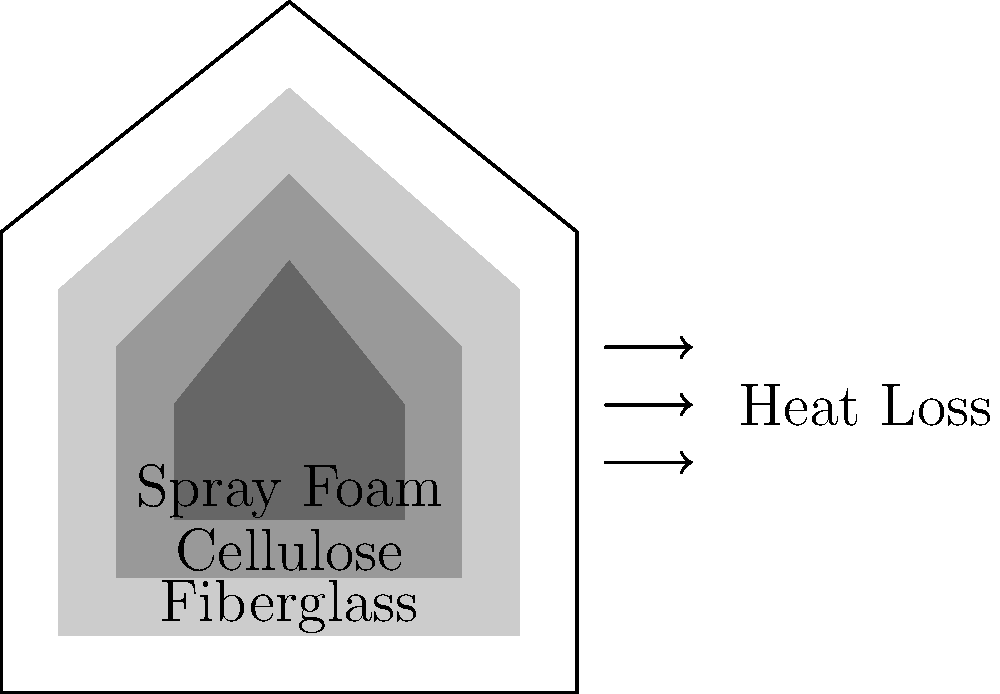In a home insulation project, three different materials are being considered: fiberglass, cellulose, and spray foam. Based on the cross-sectional diagram, which insulation material would likely provide the best thermal resistance (R-value) and reduce heat loss most effectively? Explain your reasoning considering the thickness and properties of each material. To answer this question, we need to consider the following factors:

1. Thickness: In general, thicker insulation provides better thermal resistance. From the diagram, we can see that:
   - Fiberglass is the thickest layer
   - Cellulose is the middle layer
   - Spray foam is the thinnest layer

2. Material properties:
   - Fiberglass: R-value of about 2.2 - 2.7 per inch
   - Cellulose: R-value of about 3.1 - 3.7 per inch
   - Spray foam: R-value of about 3.6 - 6.5 per inch (depending on type)

3. Thermal resistance calculation:
   The total R-value is calculated by multiplying the R-value per inch by the thickness of the material.

   Let's assume the thicknesses are:
   - Fiberglass: 6 inches
   - Cellulose: 4 inches
   - Spray foam: 2 inches

   Estimated total R-values:
   - Fiberglass: 6 * 2.5 = 15
   - Cellulose: 4 * 3.4 = 13.6
   - Spray foam: 2 * 5 = 10

4. Air sealing properties:
   Spray foam provides excellent air sealing, which can significantly reduce heat loss through air leakage.

Considering these factors, spray foam would likely provide the best thermal resistance and reduce heat loss most effectively, despite being the thinnest layer. This is because:

1. It has the highest R-value per inch
2. It provides excellent air sealing, preventing heat loss through air leakage
3. Its performance is less affected by moisture and settling over time compared to fiberglass and cellulose

While the total R-value calculation suggests fiberglass might be better, the superior air sealing properties and long-term performance of spray foam make it the most effective choice for reducing heat loss in this scenario.
Answer: Spray foam, due to its high R-value per inch and excellent air sealing properties. 